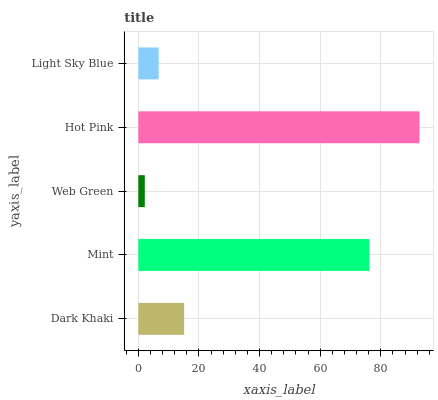Is Web Green the minimum?
Answer yes or no. Yes. Is Hot Pink the maximum?
Answer yes or no. Yes. Is Mint the minimum?
Answer yes or no. No. Is Mint the maximum?
Answer yes or no. No. Is Mint greater than Dark Khaki?
Answer yes or no. Yes. Is Dark Khaki less than Mint?
Answer yes or no. Yes. Is Dark Khaki greater than Mint?
Answer yes or no. No. Is Mint less than Dark Khaki?
Answer yes or no. No. Is Dark Khaki the high median?
Answer yes or no. Yes. Is Dark Khaki the low median?
Answer yes or no. Yes. Is Hot Pink the high median?
Answer yes or no. No. Is Hot Pink the low median?
Answer yes or no. No. 